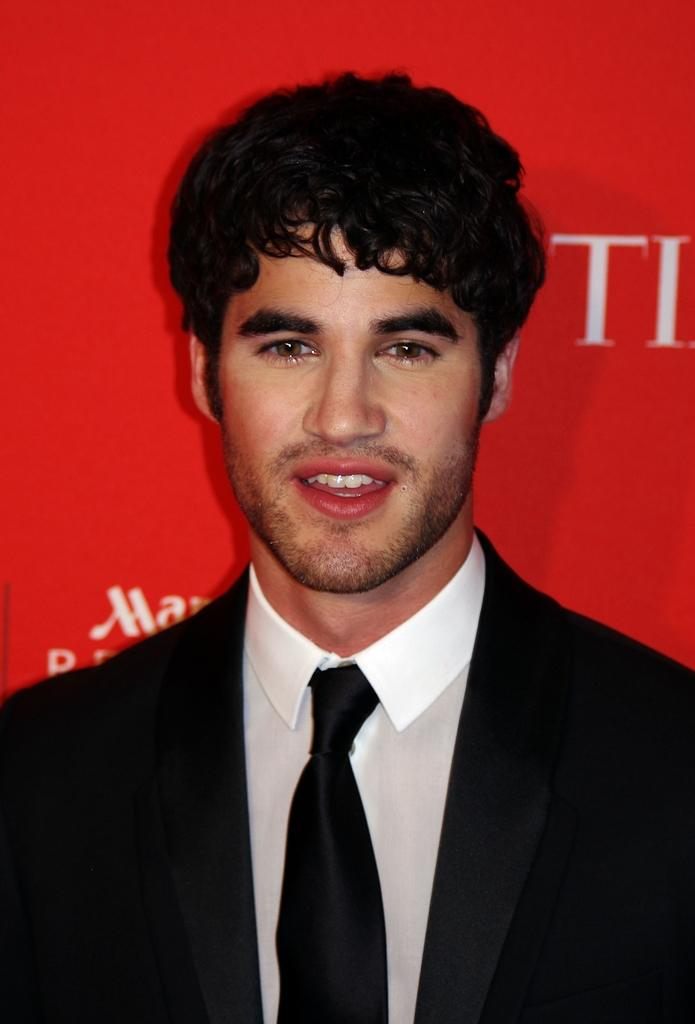Who is present in the image? There is a man in the image. What is the man wearing? The man is wearing a black suit. What color is the background of the image? The background of the image is red. What type of square creature can be seen in the image? There is no square creature present in the image. What is the man resting on in the image? The provided facts do not mention the man resting on anything, so it cannot be determined from the image. 